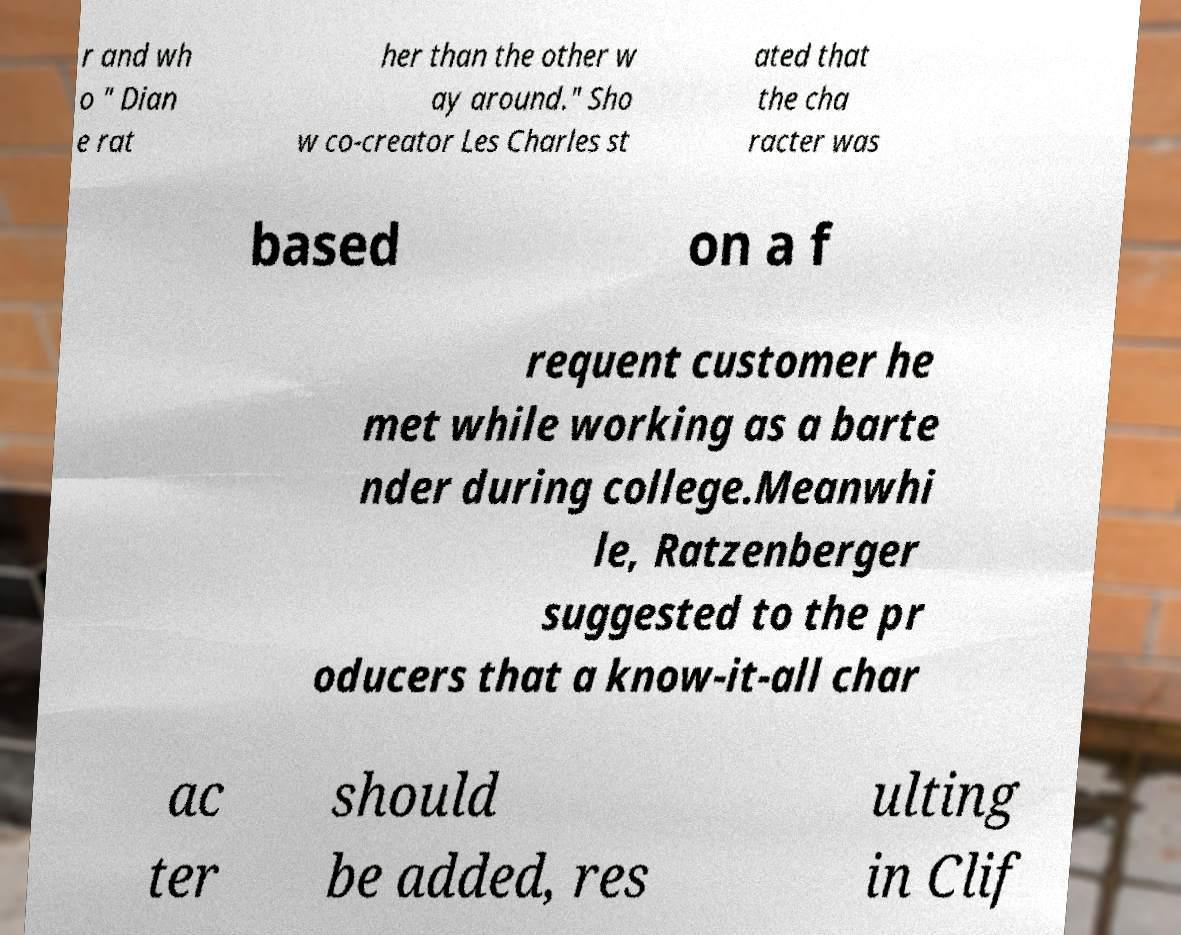Please identify and transcribe the text found in this image. r and wh o " Dian e rat her than the other w ay around." Sho w co-creator Les Charles st ated that the cha racter was based on a f requent customer he met while working as a barte nder during college.Meanwhi le, Ratzenberger suggested to the pr oducers that a know-it-all char ac ter should be added, res ulting in Clif 